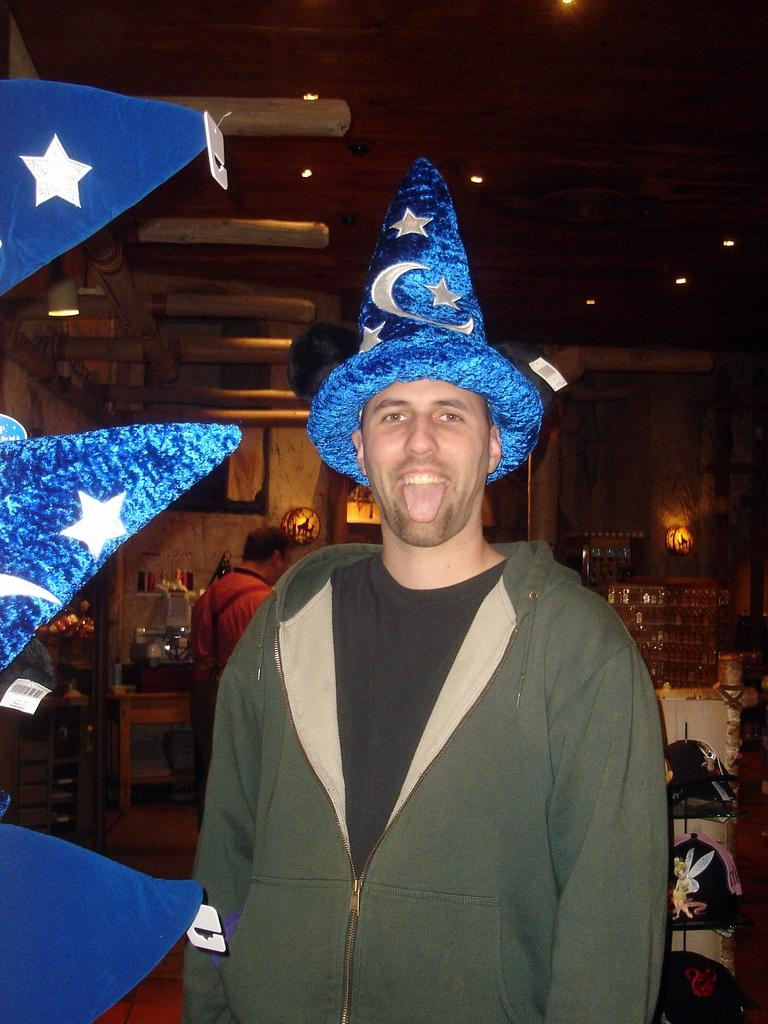What is the main subject of the image? There is a man standing in the image. What is the man wearing on his head? The man is wearing a cap on his head. Can you describe the background of the image? There is another man standing in the background. What can be seen on the ceiling in the image? There are lights on the ceiling in the image. What is present on the table in the image? There are items on the table in the image. What type of river is flowing through the image? There is no river present in the image. How does the weather affect the man's attire in the image? The provided facts do not mention any weather conditions, so we cannot determine how the weather might affect the man's attire. 